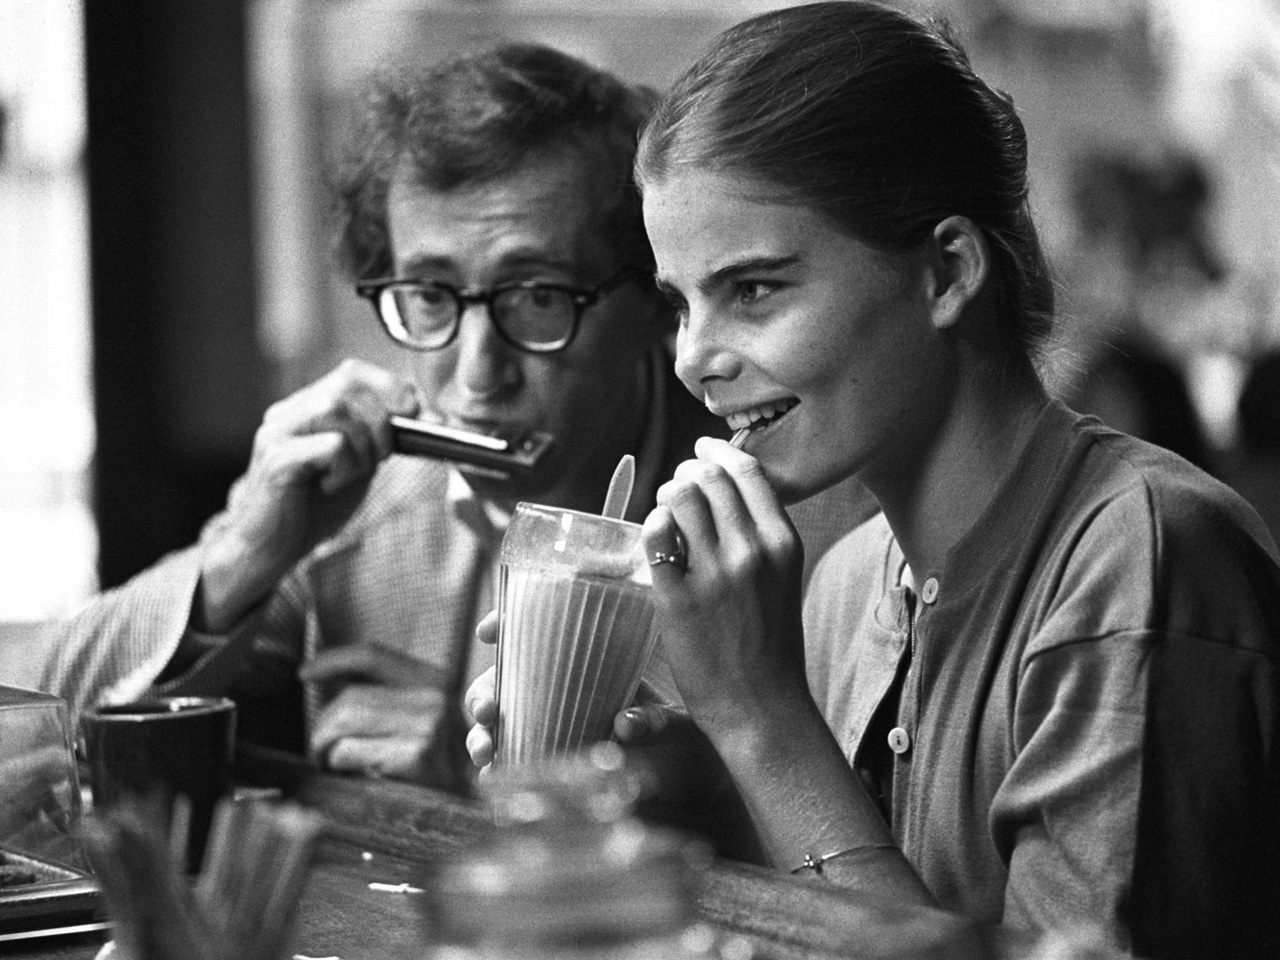Describe a day in the life of these two individuals. A day in the life of these two individuals likely starts with a casual morning at a local coffee shop, where they brainstorm new ideas over breakfast. As the day unfolds, they might head to their studio or a cozy spot in the park to work on their respective creative pursuits—be it writing, music, or another art form. Lunch could be a brief interlude at a nearby cafe, filled with lively discussion and friendly banter. The afternoon might find them collaborating on their latest project, alternating between intense focus and playful moments of improvisation. By evening, they could unwinds with friends over dinner, sharing the day’s progress and seeking fresh inspiration from their surroundings and conversations. What do you think their favorite activity to do together is? Their favorite activity to do together is likely a blend of relaxation and creativity. They enjoy visiting quaint cafes or bustling markets, absorbing the vibrant atmosphere and people-watching for inspiration. Music sessions, where one plays the harmonica and the other contributes with lyrics or storytelling, are cherished moments of artistic synergy for them. 